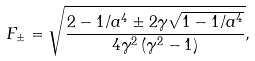Convert formula to latex. <formula><loc_0><loc_0><loc_500><loc_500>F _ { \pm } = \sqrt { \frac { 2 - 1 / a ^ { 4 } \pm 2 \gamma \sqrt { 1 - 1 / a ^ { 4 } } } { 4 \gamma ^ { 2 } \left ( \gamma ^ { 2 } - 1 \right ) } } ,</formula> 